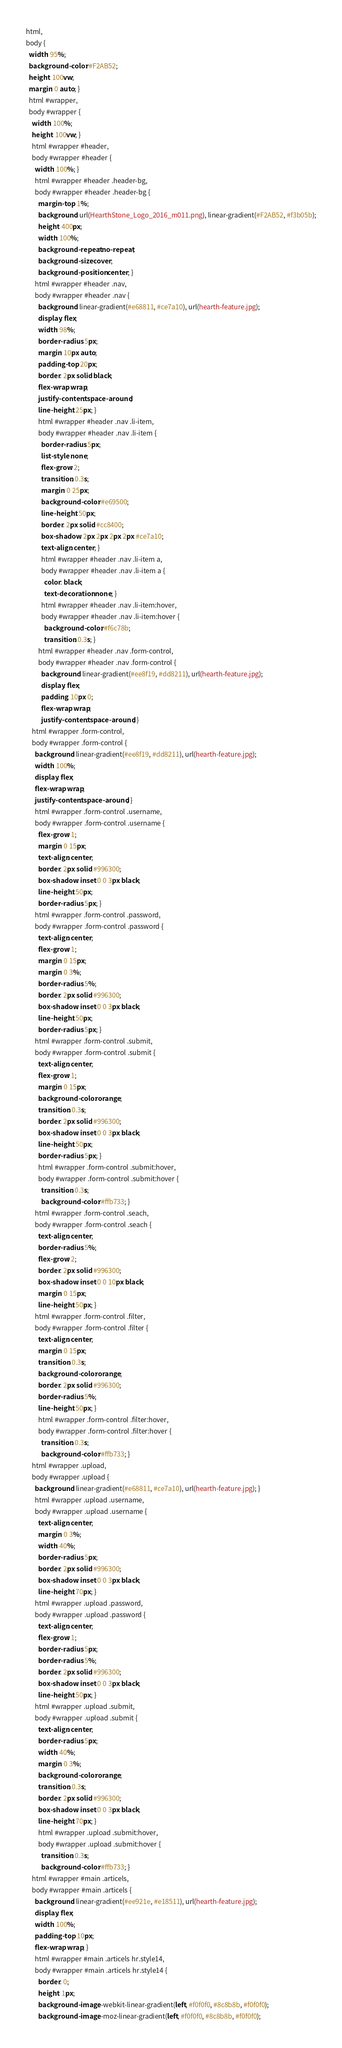Convert code to text. <code><loc_0><loc_0><loc_500><loc_500><_CSS_>html,
body {
  width: 95%;
  background-color: #F2AB52;
  height: 100vw;
  margin: 0 auto; }
  html #wrapper,
  body #wrapper {
    width: 100%;
    height: 100vw; }
    html #wrapper #header,
    body #wrapper #header {
      width: 100%; }
      html #wrapper #header .header-bg,
      body #wrapper #header .header-bg {
        margin-top: 1%;
        background: url(HearthStone_Logo_2016_m011.png), linear-gradient(#F2AB52, #f3b05b);
        height: 400px;
        width: 100%;
        background-repeat: no-repeat;
        background-size: cover;
        background-position: center; }
      html #wrapper #header .nav,
      body #wrapper #header .nav {
        background: linear-gradient(#e68811, #ce7a10), url(hearth-feature.jpg);
        display: flex;
        width: 98%;
        border-radius: 5px;
        margin: 10px auto;
        padding-top: 20px;
        border: 2px solid black;
        flex-wrap: wrap;
        justify-content: space-around;
        line-height: 25px; }
        html #wrapper #header .nav .li-item,
        body #wrapper #header .nav .li-item {
          border-radius: 5px;
          list-style: none;
          flex-grow: 2;
          transition: 0.3s;
          margin: 0 25px;
          background-color: #e69500;
          line-height: 50px;
          border: 2px solid #cc8400;
          box-shadow: 2px 2px 2px 2px #ce7a10;
          text-align: center; }
          html #wrapper #header .nav .li-item a,
          body #wrapper #header .nav .li-item a {
            color: black;
            text-decoration: none; }
          html #wrapper #header .nav .li-item:hover,
          body #wrapper #header .nav .li-item:hover {
            background-color: #f6c78b;
            transition: 0.3s; }
        html #wrapper #header .nav .form-control,
        body #wrapper #header .nav .form-control {
          background: linear-gradient(#ee8f19, #dd8211), url(hearth-feature.jpg);
          display: flex;
          padding: 10px 0;
          flex-wrap: wrap;
          justify-content: space-around; }
    html #wrapper .form-control,
    body #wrapper .form-control {
      background: linear-gradient(#ee8f19, #dd8211), url(hearth-feature.jpg);
      width: 100%;
      display: flex;
      flex-wrap: wrap;
      justify-content: space-around; }
      html #wrapper .form-control .username,
      body #wrapper .form-control .username {
        flex-grow: 1;
        margin: 0 15px;
        text-align: center;
        border: 2px solid #996300;
        box-shadow: inset 0 0 3px black;
        line-height: 50px;
        border-radius: 5px; }
      html #wrapper .form-control .password,
      body #wrapper .form-control .password {
        text-align: center;
        flex-grow: 1;
        margin: 0 15px;
        margin: 0 3%;
        border-radius: 5%;
        border: 2px solid #996300;
        box-shadow: inset 0 0 3px black;
        line-height: 50px;
        border-radius: 5px; }
      html #wrapper .form-control .submit,
      body #wrapper .form-control .submit {
        text-align: center;
        flex-grow: 1;
        margin: 0 15px;
        background-color: orange;
        transition: 0.3s;
        border: 2px solid #996300;
        box-shadow: inset 0 0 3px black;
        line-height: 50px;
        border-radius: 5px; }
        html #wrapper .form-control .submit:hover,
        body #wrapper .form-control .submit:hover {
          transition: 0.3s;
          background-color: #ffb733; }
      html #wrapper .form-control .seach,
      body #wrapper .form-control .seach {
        text-align: center;
        border-radius: 5%;
        flex-grow: 2;
        border: 2px solid #996300;
        box-shadow: inset 0 0 10px black;
        margin: 0 15px;
        line-height: 50px; }
      html #wrapper .form-control .filter,
      body #wrapper .form-control .filter {
        text-align: center;
        margin: 0 15px;
        transition: 0.3s;
        background-color: orange;
        border: 2px solid #996300;
        border-radius: 5%;
        line-height: 50px; }
        html #wrapper .form-control .filter:hover,
        body #wrapper .form-control .filter:hover {
          transition: 0.3s;
          background-color: #ffb733; }
    html #wrapper .upload,
    body #wrapper .upload {
      background: linear-gradient(#e68811, #ce7a10), url(hearth-feature.jpg); }
      html #wrapper .upload .username,
      body #wrapper .upload .username {
        text-align: center;
        margin: 0 3%;
        width: 40%;
        border-radius: 5px;
        border: 2px solid #996300;
        box-shadow: inset 0 0 3px black;
        line-height: 70px; }
      html #wrapper .upload .password,
      body #wrapper .upload .password {
        text-align: center;
        flex-grow: 1;
        border-radius: 5px;
        border-radius: 5%;
        border: 2px solid #996300;
        box-shadow: inset 0 0 3px black;
        line-height: 50px; }
      html #wrapper .upload .submit,
      body #wrapper .upload .submit {
        text-align: center;
        border-radius: 5px;
        width: 40%;
        margin: 0 3%;
        background-color: orange;
        transition: 0.3s;
        border: 2px solid #996300;
        box-shadow: inset 0 0 3px black;
        line-height: 70px; }
        html #wrapper .upload .submit:hover,
        body #wrapper .upload .submit:hover {
          transition: 0.3s;
          background-color: #ffb733; }
    html #wrapper #main .articels,
    body #wrapper #main .articels {
      background: linear-gradient(#ee921e, #e18511), url(hearth-feature.jpg);
      display: flex;
      width: 100%;
      padding-top: 10px;
      flex-wrap: wrap; }
      html #wrapper #main .articels hr.style14,
      body #wrapper #main .articels hr.style14 {
        border: 0;
        height: 1px;
        background-image: -webkit-linear-gradient(left, #f0f0f0, #8c8b8b, #f0f0f0);
        background-image: -moz-linear-gradient(left, #f0f0f0, #8c8b8b, #f0f0f0);</code> 